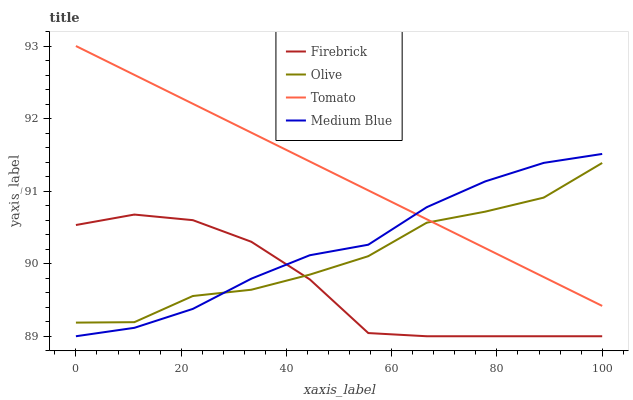Does Firebrick have the minimum area under the curve?
Answer yes or no. Yes. Does Tomato have the maximum area under the curve?
Answer yes or no. Yes. Does Tomato have the minimum area under the curve?
Answer yes or no. No. Does Firebrick have the maximum area under the curve?
Answer yes or no. No. Is Tomato the smoothest?
Answer yes or no. Yes. Is Olive the roughest?
Answer yes or no. Yes. Is Firebrick the smoothest?
Answer yes or no. No. Is Firebrick the roughest?
Answer yes or no. No. Does Firebrick have the lowest value?
Answer yes or no. Yes. Does Tomato have the lowest value?
Answer yes or no. No. Does Tomato have the highest value?
Answer yes or no. Yes. Does Firebrick have the highest value?
Answer yes or no. No. Is Firebrick less than Tomato?
Answer yes or no. Yes. Is Tomato greater than Firebrick?
Answer yes or no. Yes. Does Firebrick intersect Medium Blue?
Answer yes or no. Yes. Is Firebrick less than Medium Blue?
Answer yes or no. No. Is Firebrick greater than Medium Blue?
Answer yes or no. No. Does Firebrick intersect Tomato?
Answer yes or no. No. 